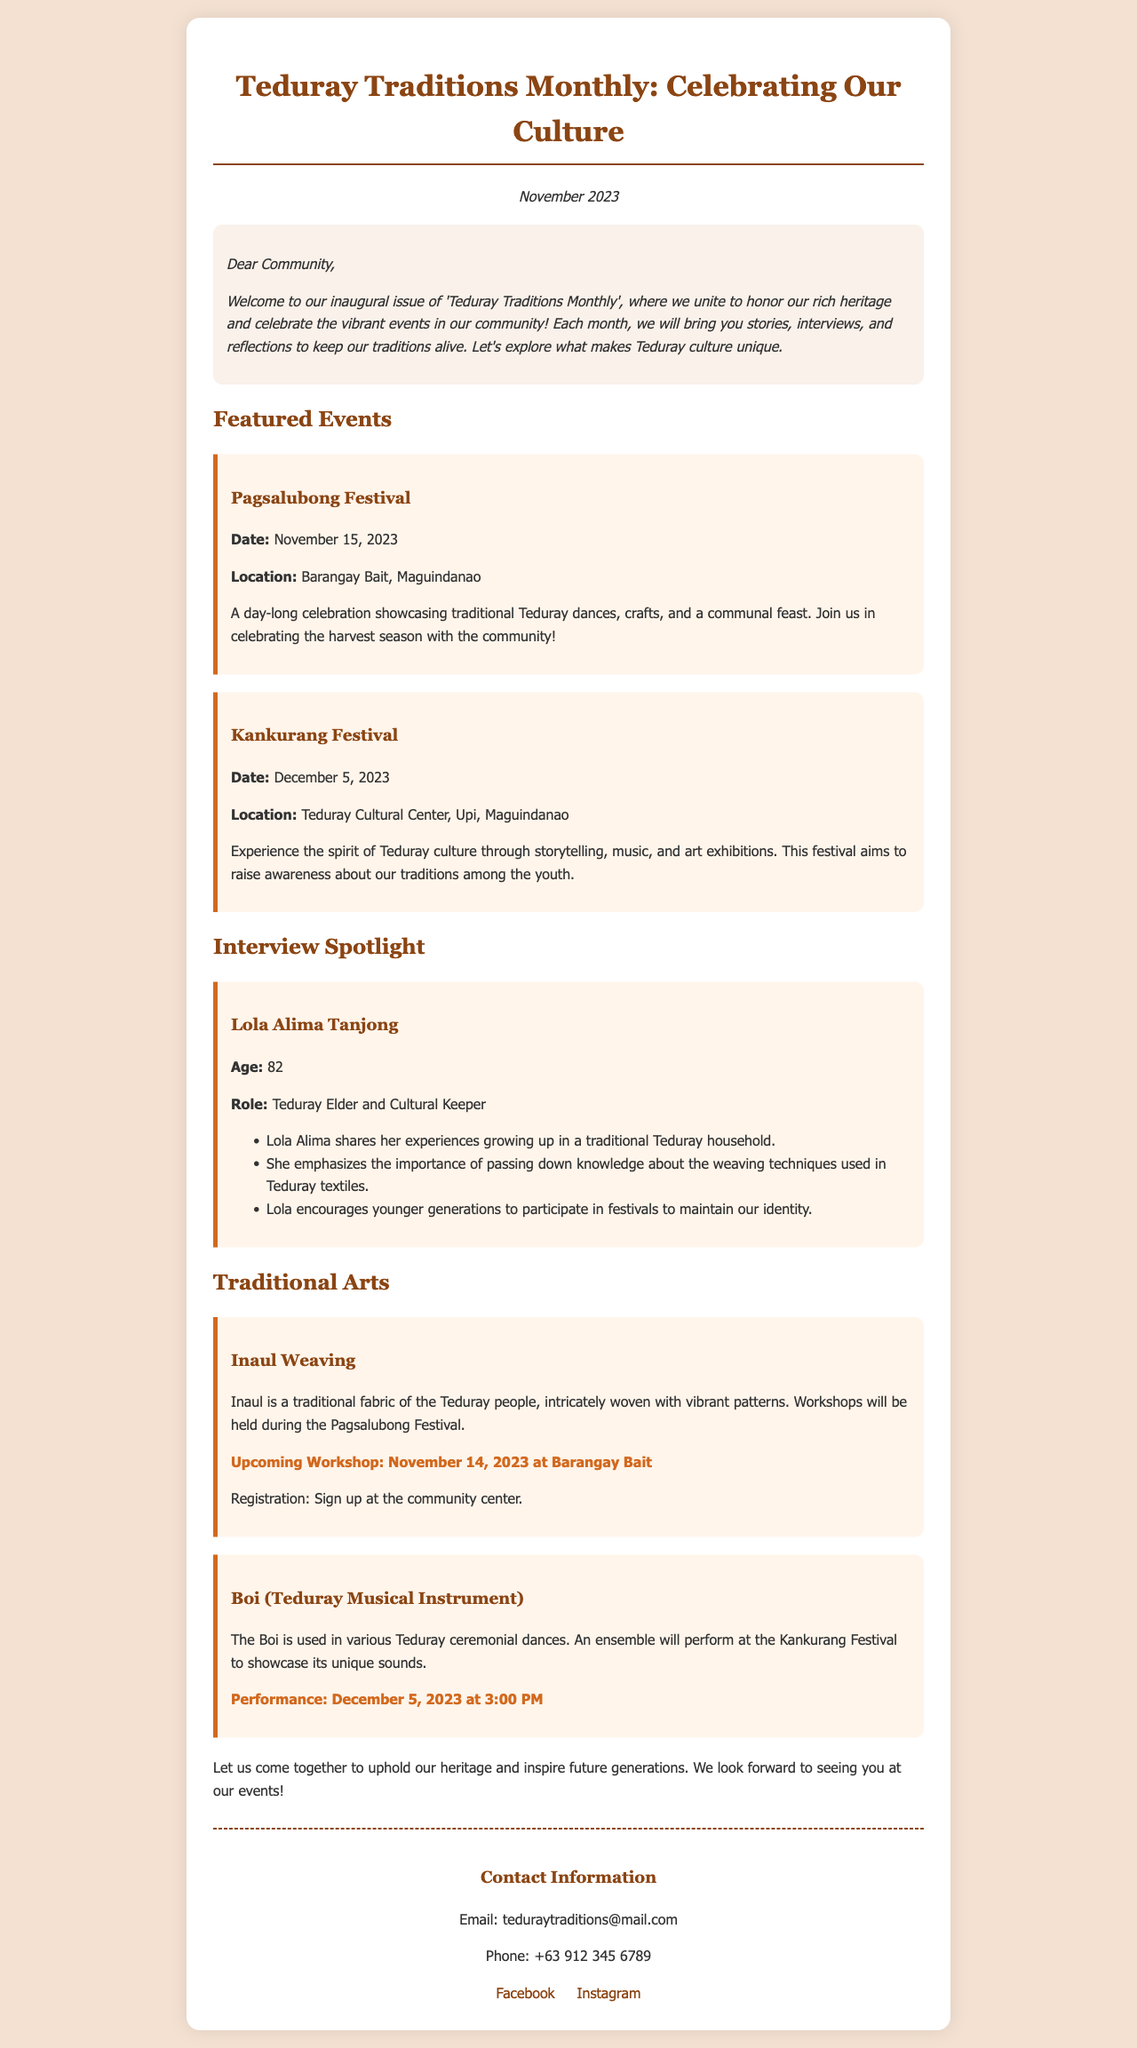What is the title of the newsletter? The title of the newsletter is stated prominently at the top of the document.
Answer: Teduray Traditions Monthly: Celebrating Our Culture What is the date of the Pagsalubong Festival? The date is specified in the event description for the Pagsalubong Festival.
Answer: November 15, 2023 Who is featured in the interview section? The document lists the name of the elder who is highlighted in the interview spotlight.
Answer: Lola Alima Tanjong What is the location of the Kankurang Festival? The location is provided in the event details for the Kankurang Festival.
Answer: Teduray Cultural Center, Upi, Maguindanao What traditional fabric is discussed in the arts section? The arts section mentions a specific fabric that is culturally significant to the Teduray people.
Answer: Inaul What age is Lola Alima Tanjong? The document includes her age in the interview spotlight section.
Answer: 82 How many workshops are held during the Pagsalubong Festival? The workshops are mentioned in the arts section along with the festival details.
Answer: 1 What is the performance time for the Boi at the Kankurang Festival? The document specifies the time for the performance of the Boi during the event.
Answer: 3:00 PM What is the contact email provided in the newsletter? The email is listed in the contact information section of the document.
Answer: teduraytraditions@mail.com 